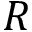Convert formula to latex. <formula><loc_0><loc_0><loc_500><loc_500>R</formula> 